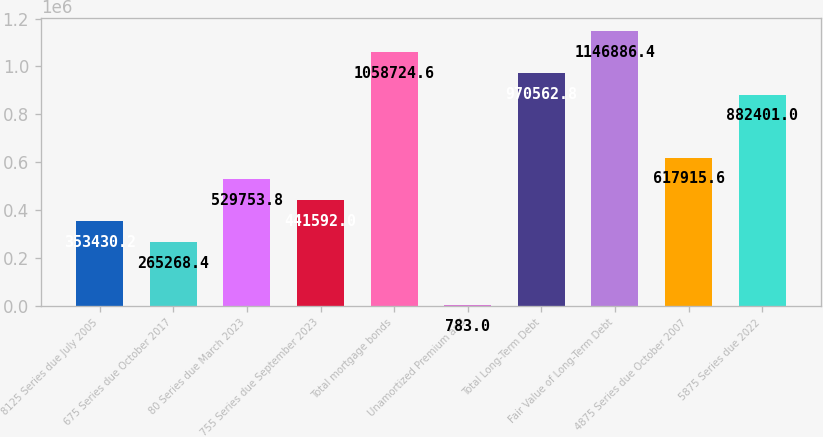Convert chart. <chart><loc_0><loc_0><loc_500><loc_500><bar_chart><fcel>8125 Series due July 2005<fcel>675 Series due October 2017<fcel>80 Series due March 2023<fcel>755 Series due September 2023<fcel>Total mortgage bonds<fcel>Unamortized Premium and<fcel>Total Long-Term Debt<fcel>Fair Value of Long-Term Debt<fcel>4875 Series due October 2007<fcel>5875 Series due 2022<nl><fcel>353430<fcel>265268<fcel>529754<fcel>441592<fcel>1.05872e+06<fcel>783<fcel>970563<fcel>1.14689e+06<fcel>617916<fcel>882401<nl></chart> 